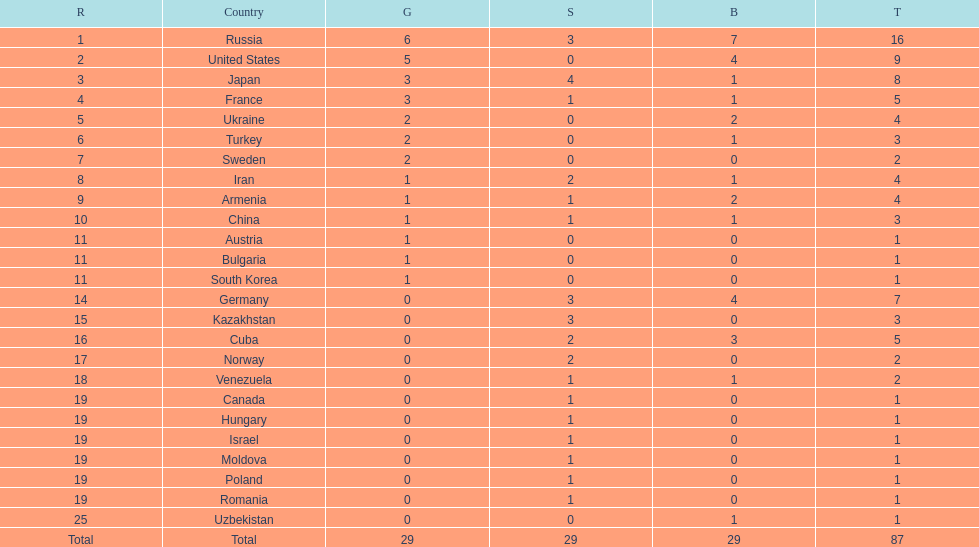What is the count of nations that have earned more than 5 bronze medals? 1. 